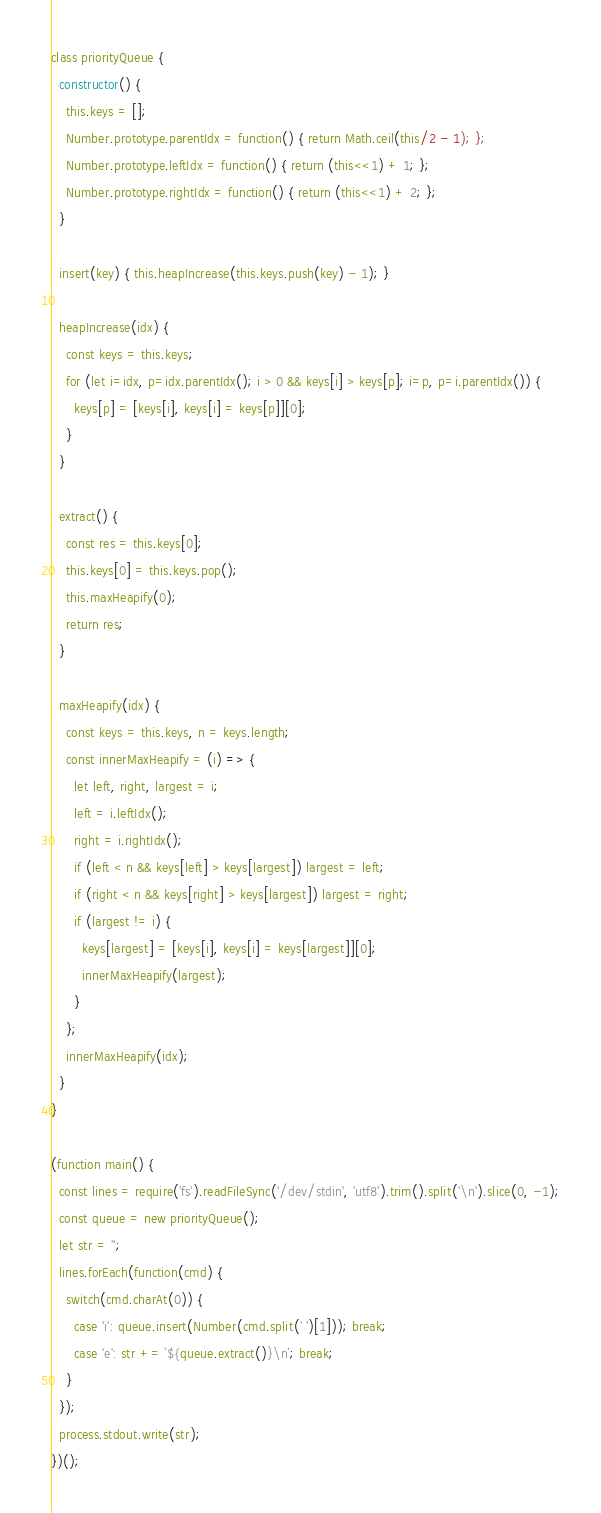<code> <loc_0><loc_0><loc_500><loc_500><_JavaScript_>class priorityQueue {
  constructor() {
    this.keys = [];
    Number.prototype.parentIdx = function() { return Math.ceil(this/2 - 1); };
    Number.prototype.leftIdx = function() { return (this<<1) + 1; };
    Number.prototype.rightIdx = function() { return (this<<1) + 2; };
  }

  insert(key) { this.heapIncrease(this.keys.push(key) - 1); }

  heapIncrease(idx) {
    const keys = this.keys;
    for (let i=idx, p=idx.parentIdx(); i > 0 && keys[i] > keys[p]; i=p, p=i.parentIdx()) {
      keys[p] = [keys[i], keys[i] = keys[p]][0];
    }
  }

  extract() {
    const res = this.keys[0];
    this.keys[0] = this.keys.pop();
    this.maxHeapify(0);
    return res;
  }

  maxHeapify(idx) {
    const keys = this.keys, n = keys.length;
    const innerMaxHeapify = (i) => {
      let left, right, largest = i;
      left = i.leftIdx();
      right = i.rightIdx();
      if (left < n && keys[left] > keys[largest]) largest = left;
      if (right < n && keys[right] > keys[largest]) largest = right;
      if (largest != i) {
        keys[largest] = [keys[i], keys[i] = keys[largest]][0];
        innerMaxHeapify(largest);
      }
    };
    innerMaxHeapify(idx);
  }
}

(function main() {
  const lines = require('fs').readFileSync('/dev/stdin', 'utf8').trim().split('\n').slice(0, -1);
  const queue = new priorityQueue();
  let str = '';
  lines.forEach(function(cmd) {
    switch(cmd.charAt(0)) {
      case 'i': queue.insert(Number(cmd.split(' ')[1])); break;
      case 'e': str += `${queue.extract()}\n`; break;
    }
  });
  process.stdout.write(str);
})();


</code> 